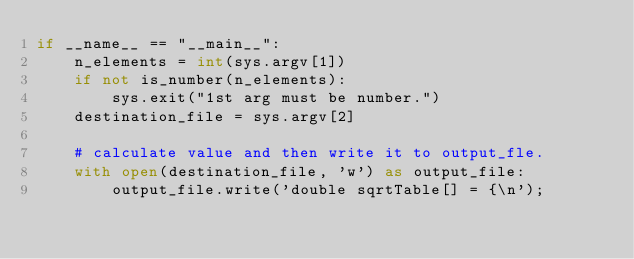Convert code to text. <code><loc_0><loc_0><loc_500><loc_500><_Python_>if __name__ == "__main__":
    n_elements = int(sys.argv[1])
    if not is_number(n_elements):
        sys.exit("1st arg must be number.")
    destination_file = sys.argv[2]

    # calculate value and then write it to output_fle.
    with open(destination_file, 'w') as output_file:
        output_file.write('double sqrtTable[] = {\n');
</code> 